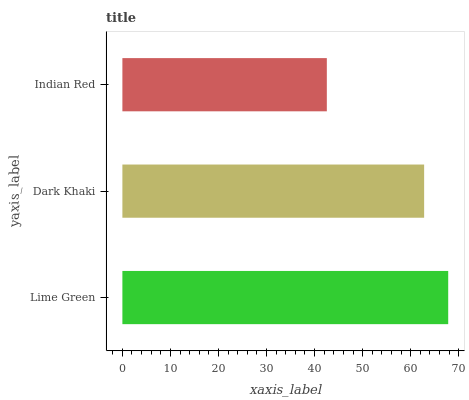Is Indian Red the minimum?
Answer yes or no. Yes. Is Lime Green the maximum?
Answer yes or no. Yes. Is Dark Khaki the minimum?
Answer yes or no. No. Is Dark Khaki the maximum?
Answer yes or no. No. Is Lime Green greater than Dark Khaki?
Answer yes or no. Yes. Is Dark Khaki less than Lime Green?
Answer yes or no. Yes. Is Dark Khaki greater than Lime Green?
Answer yes or no. No. Is Lime Green less than Dark Khaki?
Answer yes or no. No. Is Dark Khaki the high median?
Answer yes or no. Yes. Is Dark Khaki the low median?
Answer yes or no. Yes. Is Indian Red the high median?
Answer yes or no. No. Is Lime Green the low median?
Answer yes or no. No. 